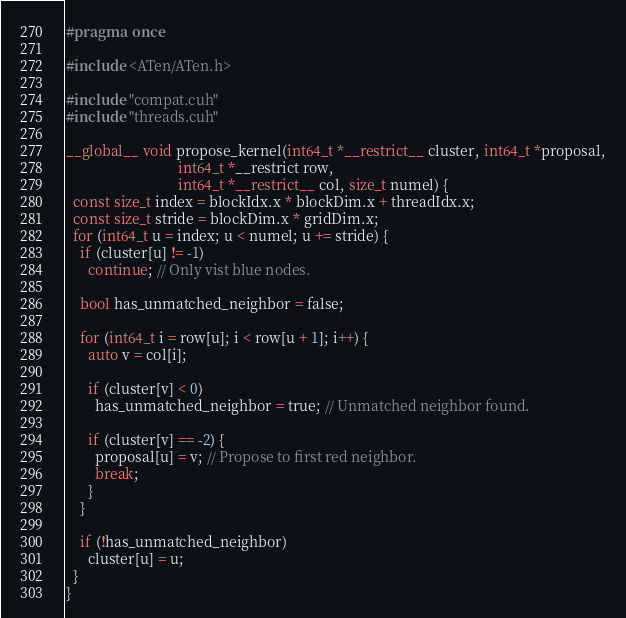Convert code to text. <code><loc_0><loc_0><loc_500><loc_500><_Cuda_>#pragma once

#include <ATen/ATen.h>

#include "compat.cuh"
#include "threads.cuh"

__global__ void propose_kernel(int64_t *__restrict__ cluster, int64_t *proposal,
                               int64_t *__restrict row,
                               int64_t *__restrict__ col, size_t numel) {
  const size_t index = blockIdx.x * blockDim.x + threadIdx.x;
  const size_t stride = blockDim.x * gridDim.x;
  for (int64_t u = index; u < numel; u += stride) {
    if (cluster[u] != -1)
      continue; // Only vist blue nodes.

    bool has_unmatched_neighbor = false;

    for (int64_t i = row[u]; i < row[u + 1]; i++) {
      auto v = col[i];

      if (cluster[v] < 0)
        has_unmatched_neighbor = true; // Unmatched neighbor found.

      if (cluster[v] == -2) {
        proposal[u] = v; // Propose to first red neighbor.
        break;
      }
    }

    if (!has_unmatched_neighbor)
      cluster[u] = u;
  }
}
</code> 